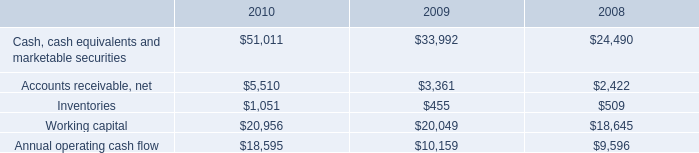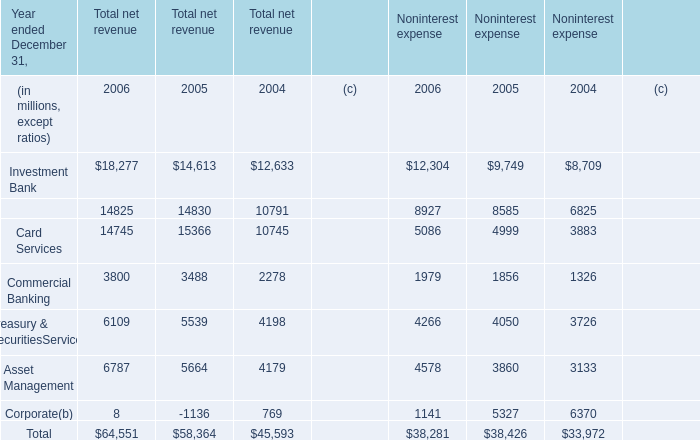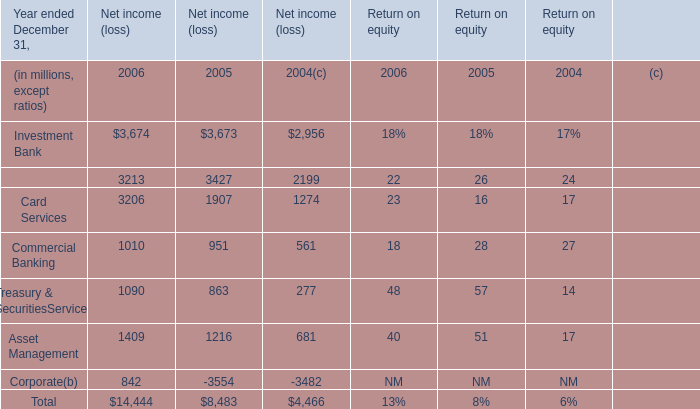When does Investment Bank reach the largest value for Net income (loss)? 
Answer: 2006. 